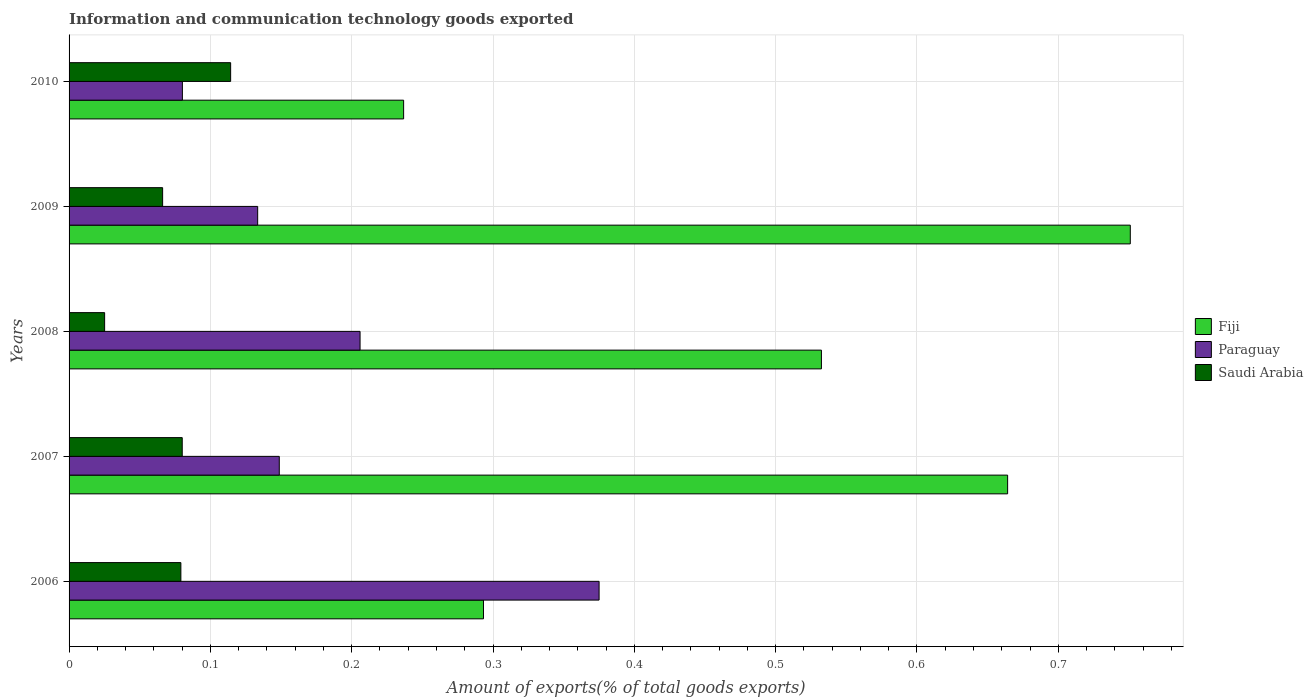Are the number of bars per tick equal to the number of legend labels?
Keep it short and to the point. Yes. Are the number of bars on each tick of the Y-axis equal?
Provide a short and direct response. Yes. How many bars are there on the 5th tick from the bottom?
Your answer should be compact. 3. What is the amount of goods exported in Saudi Arabia in 2010?
Offer a terse response. 0.11. Across all years, what is the maximum amount of goods exported in Paraguay?
Provide a succinct answer. 0.38. Across all years, what is the minimum amount of goods exported in Paraguay?
Make the answer very short. 0.08. In which year was the amount of goods exported in Saudi Arabia minimum?
Your answer should be compact. 2008. What is the total amount of goods exported in Paraguay in the graph?
Offer a terse response. 0.94. What is the difference between the amount of goods exported in Saudi Arabia in 2006 and that in 2008?
Your response must be concise. 0.05. What is the difference between the amount of goods exported in Paraguay in 2010 and the amount of goods exported in Saudi Arabia in 2007?
Your answer should be very brief. 0. What is the average amount of goods exported in Fiji per year?
Provide a succinct answer. 0.5. In the year 2009, what is the difference between the amount of goods exported in Saudi Arabia and amount of goods exported in Paraguay?
Offer a terse response. -0.07. What is the ratio of the amount of goods exported in Saudi Arabia in 2007 to that in 2009?
Your answer should be very brief. 1.21. Is the amount of goods exported in Fiji in 2007 less than that in 2010?
Provide a short and direct response. No. Is the difference between the amount of goods exported in Saudi Arabia in 2006 and 2010 greater than the difference between the amount of goods exported in Paraguay in 2006 and 2010?
Your answer should be very brief. No. What is the difference between the highest and the second highest amount of goods exported in Fiji?
Give a very brief answer. 0.09. What is the difference between the highest and the lowest amount of goods exported in Fiji?
Ensure brevity in your answer.  0.51. What does the 2nd bar from the top in 2009 represents?
Make the answer very short. Paraguay. What does the 1st bar from the bottom in 2006 represents?
Offer a terse response. Fiji. Are the values on the major ticks of X-axis written in scientific E-notation?
Ensure brevity in your answer.  No. Does the graph contain any zero values?
Your response must be concise. No. Does the graph contain grids?
Provide a short and direct response. Yes. Where does the legend appear in the graph?
Your response must be concise. Center right. How many legend labels are there?
Offer a terse response. 3. What is the title of the graph?
Ensure brevity in your answer.  Information and communication technology goods exported. Does "Ethiopia" appear as one of the legend labels in the graph?
Ensure brevity in your answer.  No. What is the label or title of the X-axis?
Keep it short and to the point. Amount of exports(% of total goods exports). What is the label or title of the Y-axis?
Offer a terse response. Years. What is the Amount of exports(% of total goods exports) of Fiji in 2006?
Offer a very short reply. 0.29. What is the Amount of exports(% of total goods exports) in Paraguay in 2006?
Offer a terse response. 0.38. What is the Amount of exports(% of total goods exports) in Saudi Arabia in 2006?
Ensure brevity in your answer.  0.08. What is the Amount of exports(% of total goods exports) of Fiji in 2007?
Provide a short and direct response. 0.66. What is the Amount of exports(% of total goods exports) of Paraguay in 2007?
Provide a succinct answer. 0.15. What is the Amount of exports(% of total goods exports) in Saudi Arabia in 2007?
Offer a very short reply. 0.08. What is the Amount of exports(% of total goods exports) of Fiji in 2008?
Ensure brevity in your answer.  0.53. What is the Amount of exports(% of total goods exports) in Paraguay in 2008?
Offer a very short reply. 0.21. What is the Amount of exports(% of total goods exports) in Saudi Arabia in 2008?
Make the answer very short. 0.03. What is the Amount of exports(% of total goods exports) in Fiji in 2009?
Your answer should be very brief. 0.75. What is the Amount of exports(% of total goods exports) of Paraguay in 2009?
Ensure brevity in your answer.  0.13. What is the Amount of exports(% of total goods exports) in Saudi Arabia in 2009?
Your answer should be very brief. 0.07. What is the Amount of exports(% of total goods exports) in Fiji in 2010?
Your response must be concise. 0.24. What is the Amount of exports(% of total goods exports) of Paraguay in 2010?
Provide a short and direct response. 0.08. What is the Amount of exports(% of total goods exports) of Saudi Arabia in 2010?
Keep it short and to the point. 0.11. Across all years, what is the maximum Amount of exports(% of total goods exports) in Fiji?
Provide a short and direct response. 0.75. Across all years, what is the maximum Amount of exports(% of total goods exports) in Paraguay?
Make the answer very short. 0.38. Across all years, what is the maximum Amount of exports(% of total goods exports) in Saudi Arabia?
Provide a succinct answer. 0.11. Across all years, what is the minimum Amount of exports(% of total goods exports) of Fiji?
Provide a short and direct response. 0.24. Across all years, what is the minimum Amount of exports(% of total goods exports) in Paraguay?
Your response must be concise. 0.08. Across all years, what is the minimum Amount of exports(% of total goods exports) in Saudi Arabia?
Your answer should be very brief. 0.03. What is the total Amount of exports(% of total goods exports) of Fiji in the graph?
Your response must be concise. 2.48. What is the total Amount of exports(% of total goods exports) in Paraguay in the graph?
Your answer should be very brief. 0.94. What is the total Amount of exports(% of total goods exports) of Saudi Arabia in the graph?
Keep it short and to the point. 0.36. What is the difference between the Amount of exports(% of total goods exports) in Fiji in 2006 and that in 2007?
Your answer should be very brief. -0.37. What is the difference between the Amount of exports(% of total goods exports) in Paraguay in 2006 and that in 2007?
Offer a terse response. 0.23. What is the difference between the Amount of exports(% of total goods exports) in Saudi Arabia in 2006 and that in 2007?
Provide a succinct answer. -0. What is the difference between the Amount of exports(% of total goods exports) in Fiji in 2006 and that in 2008?
Give a very brief answer. -0.24. What is the difference between the Amount of exports(% of total goods exports) of Paraguay in 2006 and that in 2008?
Keep it short and to the point. 0.17. What is the difference between the Amount of exports(% of total goods exports) of Saudi Arabia in 2006 and that in 2008?
Your answer should be very brief. 0.05. What is the difference between the Amount of exports(% of total goods exports) of Fiji in 2006 and that in 2009?
Keep it short and to the point. -0.46. What is the difference between the Amount of exports(% of total goods exports) of Paraguay in 2006 and that in 2009?
Make the answer very short. 0.24. What is the difference between the Amount of exports(% of total goods exports) of Saudi Arabia in 2006 and that in 2009?
Your response must be concise. 0.01. What is the difference between the Amount of exports(% of total goods exports) of Fiji in 2006 and that in 2010?
Keep it short and to the point. 0.06. What is the difference between the Amount of exports(% of total goods exports) in Paraguay in 2006 and that in 2010?
Offer a very short reply. 0.29. What is the difference between the Amount of exports(% of total goods exports) in Saudi Arabia in 2006 and that in 2010?
Provide a short and direct response. -0.04. What is the difference between the Amount of exports(% of total goods exports) of Fiji in 2007 and that in 2008?
Your response must be concise. 0.13. What is the difference between the Amount of exports(% of total goods exports) of Paraguay in 2007 and that in 2008?
Your response must be concise. -0.06. What is the difference between the Amount of exports(% of total goods exports) in Saudi Arabia in 2007 and that in 2008?
Provide a succinct answer. 0.05. What is the difference between the Amount of exports(% of total goods exports) in Fiji in 2007 and that in 2009?
Provide a short and direct response. -0.09. What is the difference between the Amount of exports(% of total goods exports) in Paraguay in 2007 and that in 2009?
Your response must be concise. 0.02. What is the difference between the Amount of exports(% of total goods exports) in Saudi Arabia in 2007 and that in 2009?
Your response must be concise. 0.01. What is the difference between the Amount of exports(% of total goods exports) of Fiji in 2007 and that in 2010?
Your response must be concise. 0.43. What is the difference between the Amount of exports(% of total goods exports) of Paraguay in 2007 and that in 2010?
Your answer should be very brief. 0.07. What is the difference between the Amount of exports(% of total goods exports) in Saudi Arabia in 2007 and that in 2010?
Keep it short and to the point. -0.03. What is the difference between the Amount of exports(% of total goods exports) in Fiji in 2008 and that in 2009?
Your answer should be compact. -0.22. What is the difference between the Amount of exports(% of total goods exports) in Paraguay in 2008 and that in 2009?
Your answer should be very brief. 0.07. What is the difference between the Amount of exports(% of total goods exports) in Saudi Arabia in 2008 and that in 2009?
Your answer should be very brief. -0.04. What is the difference between the Amount of exports(% of total goods exports) in Fiji in 2008 and that in 2010?
Ensure brevity in your answer.  0.3. What is the difference between the Amount of exports(% of total goods exports) in Paraguay in 2008 and that in 2010?
Offer a terse response. 0.13. What is the difference between the Amount of exports(% of total goods exports) of Saudi Arabia in 2008 and that in 2010?
Give a very brief answer. -0.09. What is the difference between the Amount of exports(% of total goods exports) in Fiji in 2009 and that in 2010?
Your answer should be compact. 0.51. What is the difference between the Amount of exports(% of total goods exports) in Paraguay in 2009 and that in 2010?
Make the answer very short. 0.05. What is the difference between the Amount of exports(% of total goods exports) in Saudi Arabia in 2009 and that in 2010?
Offer a terse response. -0.05. What is the difference between the Amount of exports(% of total goods exports) of Fiji in 2006 and the Amount of exports(% of total goods exports) of Paraguay in 2007?
Ensure brevity in your answer.  0.14. What is the difference between the Amount of exports(% of total goods exports) of Fiji in 2006 and the Amount of exports(% of total goods exports) of Saudi Arabia in 2007?
Keep it short and to the point. 0.21. What is the difference between the Amount of exports(% of total goods exports) in Paraguay in 2006 and the Amount of exports(% of total goods exports) in Saudi Arabia in 2007?
Provide a succinct answer. 0.29. What is the difference between the Amount of exports(% of total goods exports) of Fiji in 2006 and the Amount of exports(% of total goods exports) of Paraguay in 2008?
Offer a terse response. 0.09. What is the difference between the Amount of exports(% of total goods exports) in Fiji in 2006 and the Amount of exports(% of total goods exports) in Saudi Arabia in 2008?
Your response must be concise. 0.27. What is the difference between the Amount of exports(% of total goods exports) of Paraguay in 2006 and the Amount of exports(% of total goods exports) of Saudi Arabia in 2008?
Your answer should be compact. 0.35. What is the difference between the Amount of exports(% of total goods exports) in Fiji in 2006 and the Amount of exports(% of total goods exports) in Paraguay in 2009?
Give a very brief answer. 0.16. What is the difference between the Amount of exports(% of total goods exports) of Fiji in 2006 and the Amount of exports(% of total goods exports) of Saudi Arabia in 2009?
Your response must be concise. 0.23. What is the difference between the Amount of exports(% of total goods exports) of Paraguay in 2006 and the Amount of exports(% of total goods exports) of Saudi Arabia in 2009?
Provide a short and direct response. 0.31. What is the difference between the Amount of exports(% of total goods exports) in Fiji in 2006 and the Amount of exports(% of total goods exports) in Paraguay in 2010?
Your answer should be very brief. 0.21. What is the difference between the Amount of exports(% of total goods exports) of Fiji in 2006 and the Amount of exports(% of total goods exports) of Saudi Arabia in 2010?
Offer a terse response. 0.18. What is the difference between the Amount of exports(% of total goods exports) in Paraguay in 2006 and the Amount of exports(% of total goods exports) in Saudi Arabia in 2010?
Your answer should be very brief. 0.26. What is the difference between the Amount of exports(% of total goods exports) in Fiji in 2007 and the Amount of exports(% of total goods exports) in Paraguay in 2008?
Offer a very short reply. 0.46. What is the difference between the Amount of exports(% of total goods exports) of Fiji in 2007 and the Amount of exports(% of total goods exports) of Saudi Arabia in 2008?
Ensure brevity in your answer.  0.64. What is the difference between the Amount of exports(% of total goods exports) of Paraguay in 2007 and the Amount of exports(% of total goods exports) of Saudi Arabia in 2008?
Your answer should be compact. 0.12. What is the difference between the Amount of exports(% of total goods exports) of Fiji in 2007 and the Amount of exports(% of total goods exports) of Paraguay in 2009?
Your response must be concise. 0.53. What is the difference between the Amount of exports(% of total goods exports) of Fiji in 2007 and the Amount of exports(% of total goods exports) of Saudi Arabia in 2009?
Your answer should be compact. 0.6. What is the difference between the Amount of exports(% of total goods exports) in Paraguay in 2007 and the Amount of exports(% of total goods exports) in Saudi Arabia in 2009?
Make the answer very short. 0.08. What is the difference between the Amount of exports(% of total goods exports) of Fiji in 2007 and the Amount of exports(% of total goods exports) of Paraguay in 2010?
Keep it short and to the point. 0.58. What is the difference between the Amount of exports(% of total goods exports) of Fiji in 2007 and the Amount of exports(% of total goods exports) of Saudi Arabia in 2010?
Offer a very short reply. 0.55. What is the difference between the Amount of exports(% of total goods exports) of Paraguay in 2007 and the Amount of exports(% of total goods exports) of Saudi Arabia in 2010?
Offer a terse response. 0.03. What is the difference between the Amount of exports(% of total goods exports) in Fiji in 2008 and the Amount of exports(% of total goods exports) in Paraguay in 2009?
Your response must be concise. 0.4. What is the difference between the Amount of exports(% of total goods exports) of Fiji in 2008 and the Amount of exports(% of total goods exports) of Saudi Arabia in 2009?
Make the answer very short. 0.47. What is the difference between the Amount of exports(% of total goods exports) of Paraguay in 2008 and the Amount of exports(% of total goods exports) of Saudi Arabia in 2009?
Provide a short and direct response. 0.14. What is the difference between the Amount of exports(% of total goods exports) of Fiji in 2008 and the Amount of exports(% of total goods exports) of Paraguay in 2010?
Your answer should be very brief. 0.45. What is the difference between the Amount of exports(% of total goods exports) of Fiji in 2008 and the Amount of exports(% of total goods exports) of Saudi Arabia in 2010?
Provide a succinct answer. 0.42. What is the difference between the Amount of exports(% of total goods exports) of Paraguay in 2008 and the Amount of exports(% of total goods exports) of Saudi Arabia in 2010?
Your answer should be compact. 0.09. What is the difference between the Amount of exports(% of total goods exports) in Fiji in 2009 and the Amount of exports(% of total goods exports) in Paraguay in 2010?
Give a very brief answer. 0.67. What is the difference between the Amount of exports(% of total goods exports) in Fiji in 2009 and the Amount of exports(% of total goods exports) in Saudi Arabia in 2010?
Provide a short and direct response. 0.64. What is the difference between the Amount of exports(% of total goods exports) of Paraguay in 2009 and the Amount of exports(% of total goods exports) of Saudi Arabia in 2010?
Offer a terse response. 0.02. What is the average Amount of exports(% of total goods exports) of Fiji per year?
Your answer should be very brief. 0.5. What is the average Amount of exports(% of total goods exports) of Paraguay per year?
Your answer should be very brief. 0.19. What is the average Amount of exports(% of total goods exports) in Saudi Arabia per year?
Keep it short and to the point. 0.07. In the year 2006, what is the difference between the Amount of exports(% of total goods exports) in Fiji and Amount of exports(% of total goods exports) in Paraguay?
Make the answer very short. -0.08. In the year 2006, what is the difference between the Amount of exports(% of total goods exports) of Fiji and Amount of exports(% of total goods exports) of Saudi Arabia?
Offer a terse response. 0.21. In the year 2006, what is the difference between the Amount of exports(% of total goods exports) of Paraguay and Amount of exports(% of total goods exports) of Saudi Arabia?
Provide a succinct answer. 0.3. In the year 2007, what is the difference between the Amount of exports(% of total goods exports) in Fiji and Amount of exports(% of total goods exports) in Paraguay?
Keep it short and to the point. 0.52. In the year 2007, what is the difference between the Amount of exports(% of total goods exports) of Fiji and Amount of exports(% of total goods exports) of Saudi Arabia?
Offer a terse response. 0.58. In the year 2007, what is the difference between the Amount of exports(% of total goods exports) of Paraguay and Amount of exports(% of total goods exports) of Saudi Arabia?
Make the answer very short. 0.07. In the year 2008, what is the difference between the Amount of exports(% of total goods exports) in Fiji and Amount of exports(% of total goods exports) in Paraguay?
Your response must be concise. 0.33. In the year 2008, what is the difference between the Amount of exports(% of total goods exports) in Fiji and Amount of exports(% of total goods exports) in Saudi Arabia?
Keep it short and to the point. 0.51. In the year 2008, what is the difference between the Amount of exports(% of total goods exports) in Paraguay and Amount of exports(% of total goods exports) in Saudi Arabia?
Your answer should be very brief. 0.18. In the year 2009, what is the difference between the Amount of exports(% of total goods exports) in Fiji and Amount of exports(% of total goods exports) in Paraguay?
Provide a succinct answer. 0.62. In the year 2009, what is the difference between the Amount of exports(% of total goods exports) of Fiji and Amount of exports(% of total goods exports) of Saudi Arabia?
Your answer should be very brief. 0.68. In the year 2009, what is the difference between the Amount of exports(% of total goods exports) in Paraguay and Amount of exports(% of total goods exports) in Saudi Arabia?
Make the answer very short. 0.07. In the year 2010, what is the difference between the Amount of exports(% of total goods exports) of Fiji and Amount of exports(% of total goods exports) of Paraguay?
Give a very brief answer. 0.16. In the year 2010, what is the difference between the Amount of exports(% of total goods exports) of Fiji and Amount of exports(% of total goods exports) of Saudi Arabia?
Ensure brevity in your answer.  0.12. In the year 2010, what is the difference between the Amount of exports(% of total goods exports) of Paraguay and Amount of exports(% of total goods exports) of Saudi Arabia?
Provide a short and direct response. -0.03. What is the ratio of the Amount of exports(% of total goods exports) in Fiji in 2006 to that in 2007?
Your answer should be compact. 0.44. What is the ratio of the Amount of exports(% of total goods exports) in Paraguay in 2006 to that in 2007?
Your answer should be very brief. 2.52. What is the ratio of the Amount of exports(% of total goods exports) of Saudi Arabia in 2006 to that in 2007?
Your answer should be very brief. 0.99. What is the ratio of the Amount of exports(% of total goods exports) of Fiji in 2006 to that in 2008?
Make the answer very short. 0.55. What is the ratio of the Amount of exports(% of total goods exports) in Paraguay in 2006 to that in 2008?
Keep it short and to the point. 1.82. What is the ratio of the Amount of exports(% of total goods exports) in Saudi Arabia in 2006 to that in 2008?
Your answer should be very brief. 3.14. What is the ratio of the Amount of exports(% of total goods exports) in Fiji in 2006 to that in 2009?
Offer a terse response. 0.39. What is the ratio of the Amount of exports(% of total goods exports) in Paraguay in 2006 to that in 2009?
Provide a short and direct response. 2.81. What is the ratio of the Amount of exports(% of total goods exports) of Saudi Arabia in 2006 to that in 2009?
Offer a terse response. 1.2. What is the ratio of the Amount of exports(% of total goods exports) in Fiji in 2006 to that in 2010?
Make the answer very short. 1.24. What is the ratio of the Amount of exports(% of total goods exports) in Paraguay in 2006 to that in 2010?
Provide a short and direct response. 4.68. What is the ratio of the Amount of exports(% of total goods exports) in Saudi Arabia in 2006 to that in 2010?
Give a very brief answer. 0.69. What is the ratio of the Amount of exports(% of total goods exports) of Fiji in 2007 to that in 2008?
Your answer should be very brief. 1.25. What is the ratio of the Amount of exports(% of total goods exports) in Paraguay in 2007 to that in 2008?
Your response must be concise. 0.72. What is the ratio of the Amount of exports(% of total goods exports) in Saudi Arabia in 2007 to that in 2008?
Make the answer very short. 3.18. What is the ratio of the Amount of exports(% of total goods exports) in Fiji in 2007 to that in 2009?
Make the answer very short. 0.88. What is the ratio of the Amount of exports(% of total goods exports) of Paraguay in 2007 to that in 2009?
Ensure brevity in your answer.  1.11. What is the ratio of the Amount of exports(% of total goods exports) in Saudi Arabia in 2007 to that in 2009?
Your answer should be very brief. 1.21. What is the ratio of the Amount of exports(% of total goods exports) of Fiji in 2007 to that in 2010?
Offer a very short reply. 2.81. What is the ratio of the Amount of exports(% of total goods exports) of Paraguay in 2007 to that in 2010?
Provide a succinct answer. 1.86. What is the ratio of the Amount of exports(% of total goods exports) in Saudi Arabia in 2007 to that in 2010?
Give a very brief answer. 0.7. What is the ratio of the Amount of exports(% of total goods exports) in Fiji in 2008 to that in 2009?
Provide a short and direct response. 0.71. What is the ratio of the Amount of exports(% of total goods exports) in Paraguay in 2008 to that in 2009?
Offer a very short reply. 1.54. What is the ratio of the Amount of exports(% of total goods exports) in Saudi Arabia in 2008 to that in 2009?
Offer a terse response. 0.38. What is the ratio of the Amount of exports(% of total goods exports) of Fiji in 2008 to that in 2010?
Provide a short and direct response. 2.25. What is the ratio of the Amount of exports(% of total goods exports) in Paraguay in 2008 to that in 2010?
Offer a terse response. 2.57. What is the ratio of the Amount of exports(% of total goods exports) of Saudi Arabia in 2008 to that in 2010?
Offer a terse response. 0.22. What is the ratio of the Amount of exports(% of total goods exports) in Fiji in 2009 to that in 2010?
Offer a terse response. 3.17. What is the ratio of the Amount of exports(% of total goods exports) in Paraguay in 2009 to that in 2010?
Keep it short and to the point. 1.66. What is the ratio of the Amount of exports(% of total goods exports) of Saudi Arabia in 2009 to that in 2010?
Your answer should be compact. 0.58. What is the difference between the highest and the second highest Amount of exports(% of total goods exports) in Fiji?
Make the answer very short. 0.09. What is the difference between the highest and the second highest Amount of exports(% of total goods exports) in Paraguay?
Give a very brief answer. 0.17. What is the difference between the highest and the second highest Amount of exports(% of total goods exports) of Saudi Arabia?
Offer a terse response. 0.03. What is the difference between the highest and the lowest Amount of exports(% of total goods exports) of Fiji?
Make the answer very short. 0.51. What is the difference between the highest and the lowest Amount of exports(% of total goods exports) of Paraguay?
Offer a very short reply. 0.29. What is the difference between the highest and the lowest Amount of exports(% of total goods exports) in Saudi Arabia?
Your answer should be compact. 0.09. 